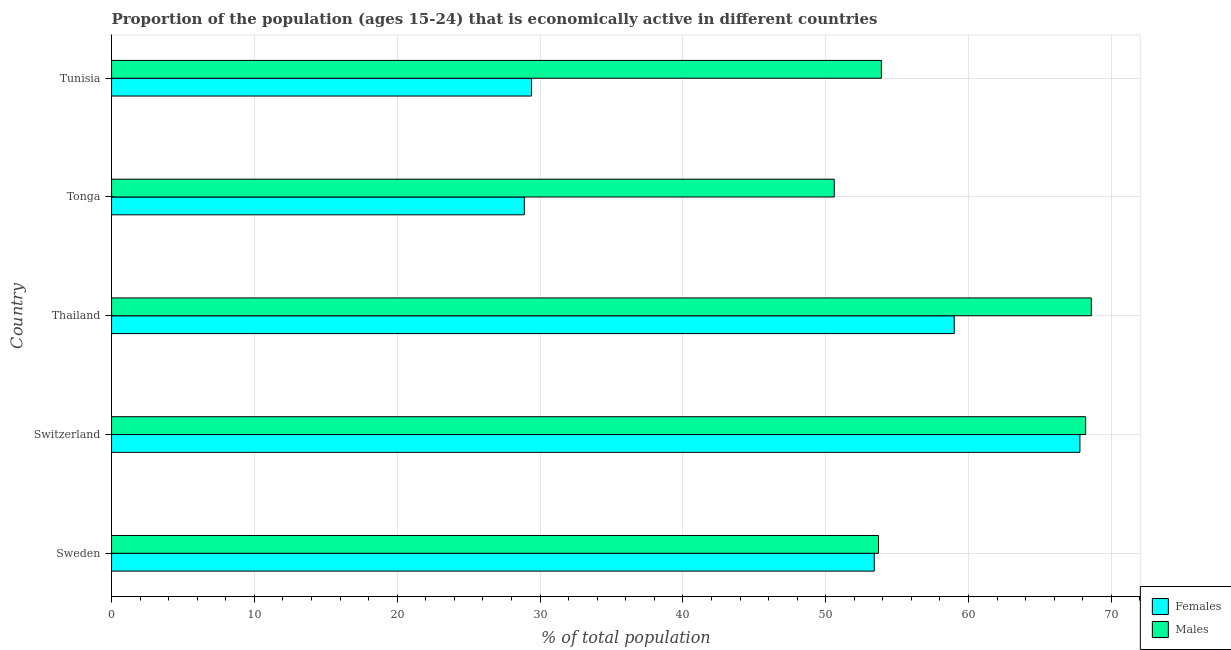How many bars are there on the 2nd tick from the top?
Your answer should be compact. 2. How many bars are there on the 5th tick from the bottom?
Provide a short and direct response. 2. In how many cases, is the number of bars for a given country not equal to the number of legend labels?
Offer a very short reply. 0. What is the percentage of economically active male population in Tunisia?
Keep it short and to the point. 53.9. Across all countries, what is the maximum percentage of economically active male population?
Your answer should be very brief. 68.6. Across all countries, what is the minimum percentage of economically active male population?
Your answer should be very brief. 50.6. In which country was the percentage of economically active female population maximum?
Give a very brief answer. Switzerland. In which country was the percentage of economically active female population minimum?
Your answer should be compact. Tonga. What is the total percentage of economically active female population in the graph?
Give a very brief answer. 238.5. What is the difference between the percentage of economically active female population in Thailand and the percentage of economically active male population in Switzerland?
Provide a succinct answer. -9.2. What is the average percentage of economically active female population per country?
Keep it short and to the point. 47.7. What is the difference between the percentage of economically active female population and percentage of economically active male population in Thailand?
Provide a short and direct response. -9.6. What is the ratio of the percentage of economically active male population in Switzerland to that in Thailand?
Give a very brief answer. 0.99. Is the percentage of economically active female population in Sweden less than that in Switzerland?
Your response must be concise. Yes. Is the sum of the percentage of economically active male population in Sweden and Tonga greater than the maximum percentage of economically active female population across all countries?
Your answer should be compact. Yes. What does the 1st bar from the top in Switzerland represents?
Offer a terse response. Males. What does the 1st bar from the bottom in Tonga represents?
Your answer should be compact. Females. How many bars are there?
Ensure brevity in your answer.  10. How many countries are there in the graph?
Offer a terse response. 5. What is the difference between two consecutive major ticks on the X-axis?
Ensure brevity in your answer.  10. Does the graph contain grids?
Offer a very short reply. Yes. Where does the legend appear in the graph?
Offer a very short reply. Bottom right. How are the legend labels stacked?
Ensure brevity in your answer.  Vertical. What is the title of the graph?
Provide a succinct answer. Proportion of the population (ages 15-24) that is economically active in different countries. Does "Male population" appear as one of the legend labels in the graph?
Give a very brief answer. No. What is the label or title of the X-axis?
Keep it short and to the point. % of total population. What is the % of total population of Females in Sweden?
Your answer should be very brief. 53.4. What is the % of total population of Males in Sweden?
Make the answer very short. 53.7. What is the % of total population in Females in Switzerland?
Your response must be concise. 67.8. What is the % of total population of Males in Switzerland?
Your response must be concise. 68.2. What is the % of total population of Females in Thailand?
Provide a succinct answer. 59. What is the % of total population of Males in Thailand?
Offer a terse response. 68.6. What is the % of total population in Females in Tonga?
Offer a very short reply. 28.9. What is the % of total population in Males in Tonga?
Your answer should be compact. 50.6. What is the % of total population in Females in Tunisia?
Offer a very short reply. 29.4. What is the % of total population in Males in Tunisia?
Your answer should be very brief. 53.9. Across all countries, what is the maximum % of total population of Females?
Ensure brevity in your answer.  67.8. Across all countries, what is the maximum % of total population of Males?
Your answer should be compact. 68.6. Across all countries, what is the minimum % of total population in Females?
Offer a very short reply. 28.9. Across all countries, what is the minimum % of total population of Males?
Make the answer very short. 50.6. What is the total % of total population in Females in the graph?
Your answer should be very brief. 238.5. What is the total % of total population in Males in the graph?
Your answer should be compact. 295. What is the difference between the % of total population in Females in Sweden and that in Switzerland?
Make the answer very short. -14.4. What is the difference between the % of total population of Males in Sweden and that in Thailand?
Give a very brief answer. -14.9. What is the difference between the % of total population in Females in Sweden and that in Tonga?
Provide a short and direct response. 24.5. What is the difference between the % of total population in Males in Sweden and that in Tonga?
Your answer should be very brief. 3.1. What is the difference between the % of total population of Females in Sweden and that in Tunisia?
Provide a succinct answer. 24. What is the difference between the % of total population in Females in Switzerland and that in Thailand?
Provide a short and direct response. 8.8. What is the difference between the % of total population in Females in Switzerland and that in Tonga?
Make the answer very short. 38.9. What is the difference between the % of total population in Females in Switzerland and that in Tunisia?
Offer a terse response. 38.4. What is the difference between the % of total population in Males in Switzerland and that in Tunisia?
Ensure brevity in your answer.  14.3. What is the difference between the % of total population in Females in Thailand and that in Tonga?
Keep it short and to the point. 30.1. What is the difference between the % of total population in Females in Thailand and that in Tunisia?
Provide a succinct answer. 29.6. What is the difference between the % of total population in Females in Sweden and the % of total population in Males in Switzerland?
Give a very brief answer. -14.8. What is the difference between the % of total population in Females in Sweden and the % of total population in Males in Thailand?
Keep it short and to the point. -15.2. What is the difference between the % of total population of Females in Sweden and the % of total population of Males in Tonga?
Your response must be concise. 2.8. What is the difference between the % of total population of Females in Thailand and the % of total population of Males in Tonga?
Keep it short and to the point. 8.4. What is the difference between the % of total population in Females in Thailand and the % of total population in Males in Tunisia?
Your response must be concise. 5.1. What is the average % of total population in Females per country?
Your response must be concise. 47.7. What is the difference between the % of total population of Females and % of total population of Males in Sweden?
Make the answer very short. -0.3. What is the difference between the % of total population in Females and % of total population in Males in Tonga?
Your response must be concise. -21.7. What is the difference between the % of total population of Females and % of total population of Males in Tunisia?
Give a very brief answer. -24.5. What is the ratio of the % of total population of Females in Sweden to that in Switzerland?
Give a very brief answer. 0.79. What is the ratio of the % of total population in Males in Sweden to that in Switzerland?
Your response must be concise. 0.79. What is the ratio of the % of total population of Females in Sweden to that in Thailand?
Provide a succinct answer. 0.91. What is the ratio of the % of total population in Males in Sweden to that in Thailand?
Your answer should be compact. 0.78. What is the ratio of the % of total population in Females in Sweden to that in Tonga?
Make the answer very short. 1.85. What is the ratio of the % of total population of Males in Sweden to that in Tonga?
Offer a terse response. 1.06. What is the ratio of the % of total population in Females in Sweden to that in Tunisia?
Your answer should be compact. 1.82. What is the ratio of the % of total population of Females in Switzerland to that in Thailand?
Give a very brief answer. 1.15. What is the ratio of the % of total population of Males in Switzerland to that in Thailand?
Make the answer very short. 0.99. What is the ratio of the % of total population in Females in Switzerland to that in Tonga?
Your response must be concise. 2.35. What is the ratio of the % of total population of Males in Switzerland to that in Tonga?
Provide a short and direct response. 1.35. What is the ratio of the % of total population of Females in Switzerland to that in Tunisia?
Keep it short and to the point. 2.31. What is the ratio of the % of total population in Males in Switzerland to that in Tunisia?
Keep it short and to the point. 1.27. What is the ratio of the % of total population of Females in Thailand to that in Tonga?
Keep it short and to the point. 2.04. What is the ratio of the % of total population of Males in Thailand to that in Tonga?
Provide a succinct answer. 1.36. What is the ratio of the % of total population in Females in Thailand to that in Tunisia?
Make the answer very short. 2.01. What is the ratio of the % of total population in Males in Thailand to that in Tunisia?
Your answer should be very brief. 1.27. What is the ratio of the % of total population of Females in Tonga to that in Tunisia?
Make the answer very short. 0.98. What is the ratio of the % of total population of Males in Tonga to that in Tunisia?
Give a very brief answer. 0.94. What is the difference between the highest and the second highest % of total population in Females?
Offer a very short reply. 8.8. What is the difference between the highest and the second highest % of total population in Males?
Ensure brevity in your answer.  0.4. What is the difference between the highest and the lowest % of total population in Females?
Ensure brevity in your answer.  38.9. What is the difference between the highest and the lowest % of total population of Males?
Make the answer very short. 18. 